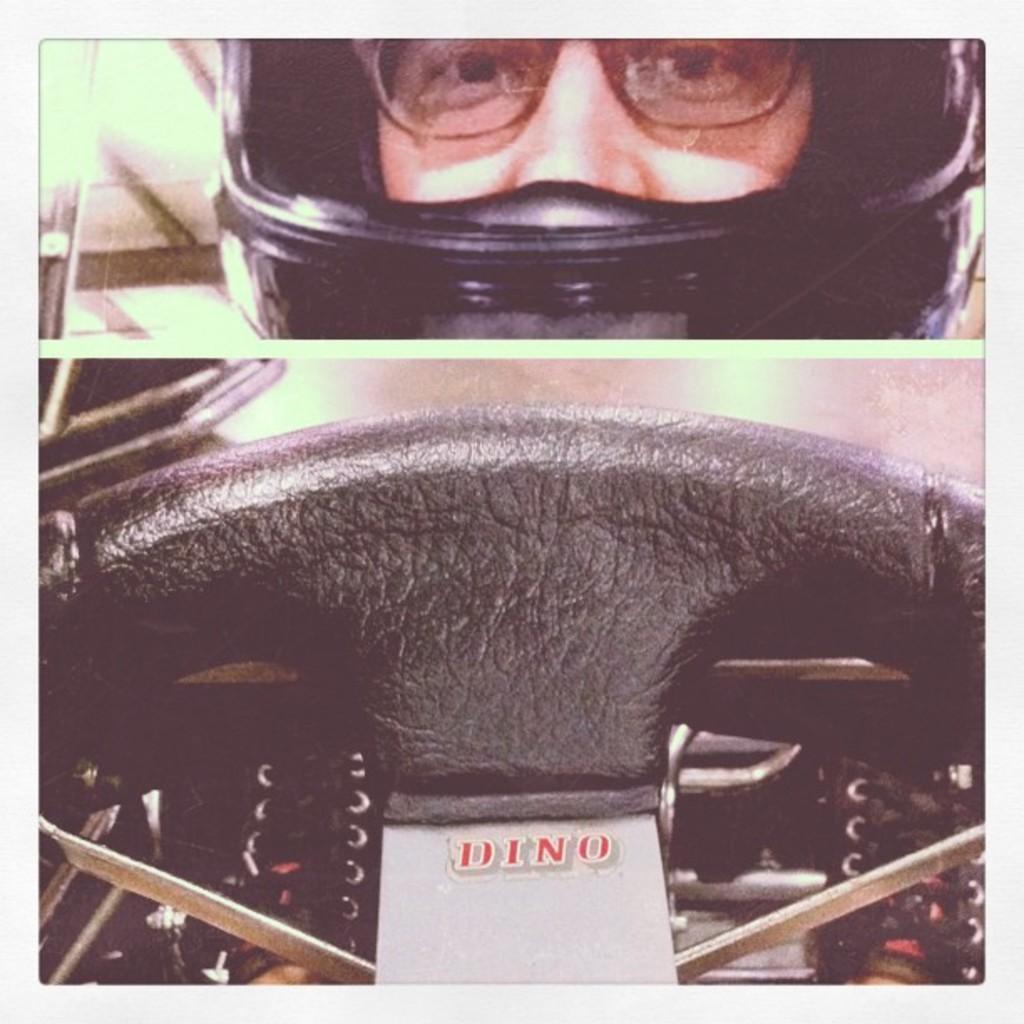What type of picture is in the image? There is a collage picture in the image. What is included in the collage picture? The collage picture contains a steering wheel. What is the color of the steering wheel? The steering wheel is black in color. Who is present in the collage picture? There is a person in the collage picture. What is the person wearing on their head? The person is wearing a black-colored helmet. What accessory is the person wearing on their face? The person is wearing spectacles. How many cherries are on the credit card in the image? There is no credit card or cherry present in the image. What type of division is taking place in the image? There is no division or reference to division in the image. 